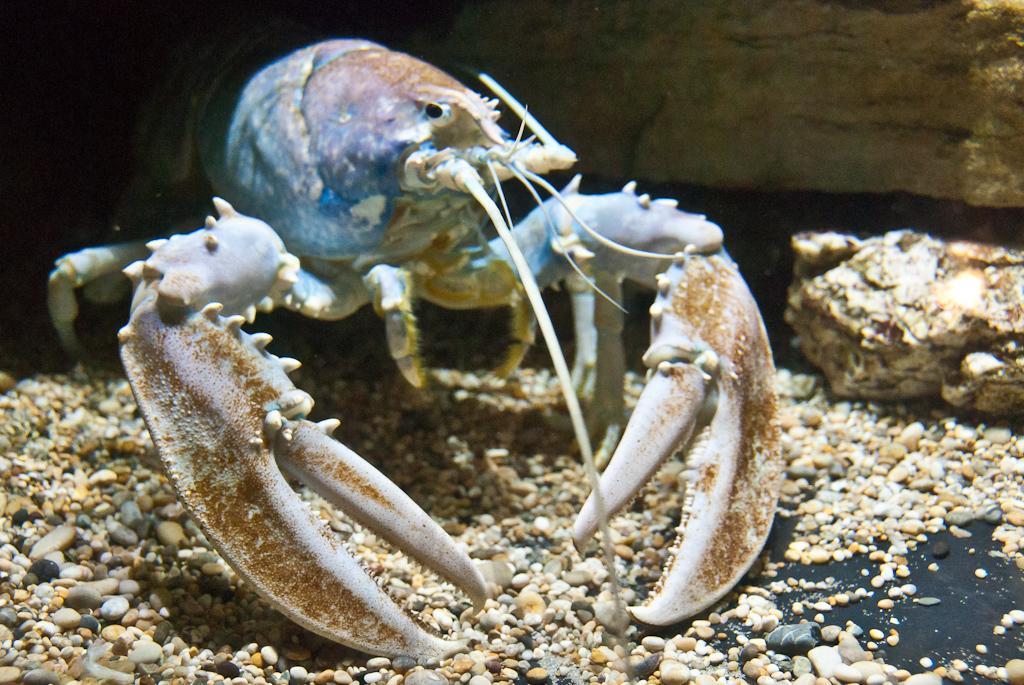Could you give a brief overview of what you see in this image? In the center of the image we can see a lobster on the stones. In the background there is a wall and a rock. 